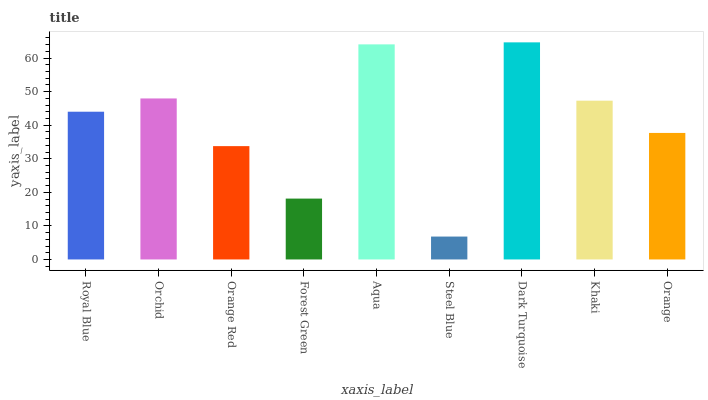Is Steel Blue the minimum?
Answer yes or no. Yes. Is Dark Turquoise the maximum?
Answer yes or no. Yes. Is Orchid the minimum?
Answer yes or no. No. Is Orchid the maximum?
Answer yes or no. No. Is Orchid greater than Royal Blue?
Answer yes or no. Yes. Is Royal Blue less than Orchid?
Answer yes or no. Yes. Is Royal Blue greater than Orchid?
Answer yes or no. No. Is Orchid less than Royal Blue?
Answer yes or no. No. Is Royal Blue the high median?
Answer yes or no. Yes. Is Royal Blue the low median?
Answer yes or no. Yes. Is Steel Blue the high median?
Answer yes or no. No. Is Khaki the low median?
Answer yes or no. No. 